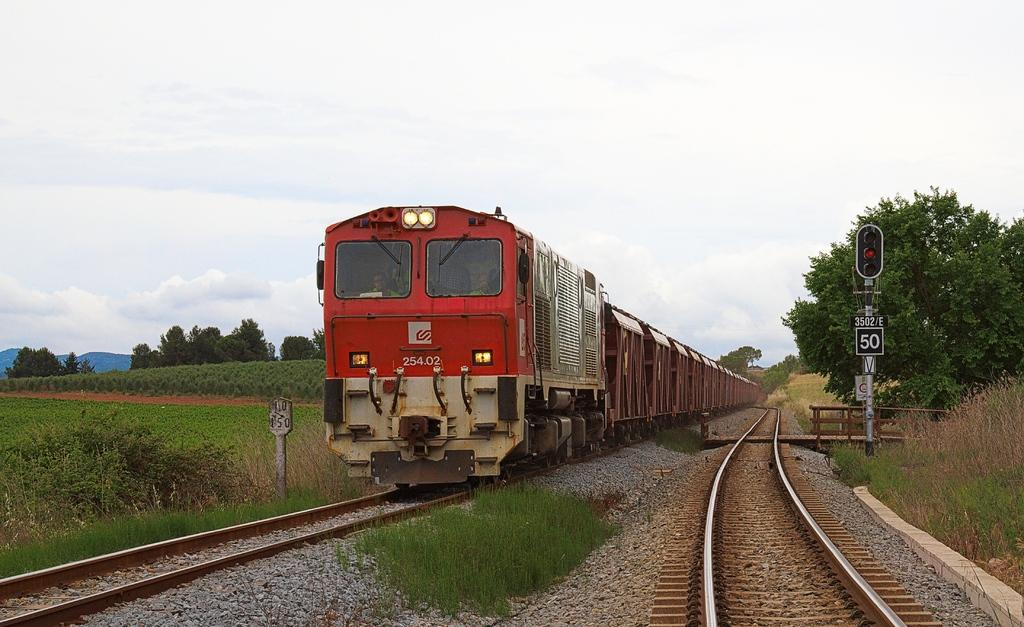<image>
Write a terse but informative summary of the picture. A red train bears the numbers 254.02 on the front. 